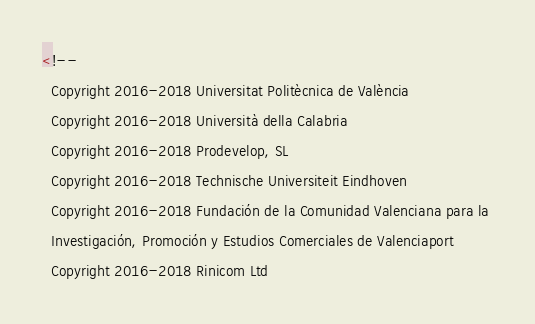Convert code to text. <code><loc_0><loc_0><loc_500><loc_500><_HTML_><!-- 
  Copyright 2016-2018 Universitat Politècnica de València
  Copyright 2016-2018 Università della Calabria
  Copyright 2016-2018 Prodevelop, SL
  Copyright 2016-2018 Technische Universiteit Eindhoven
  Copyright 2016-2018 Fundación de la Comunidad Valenciana para la 
  Investigación, Promoción y Estudios Comerciales de Valenciaport
  Copyright 2016-2018 Rinicom Ltd</code> 